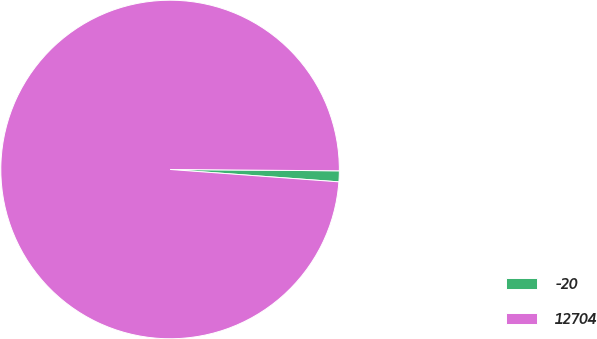<chart> <loc_0><loc_0><loc_500><loc_500><pie_chart><fcel>-20<fcel>12704<nl><fcel>1.04%<fcel>98.96%<nl></chart> 